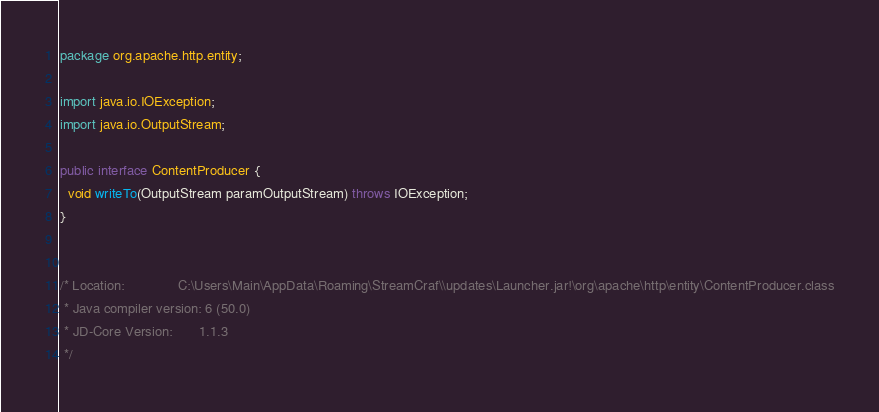<code> <loc_0><loc_0><loc_500><loc_500><_Java_>package org.apache.http.entity;

import java.io.IOException;
import java.io.OutputStream;

public interface ContentProducer {
  void writeTo(OutputStream paramOutputStream) throws IOException;
}


/* Location:              C:\Users\Main\AppData\Roaming\StreamCraf\\updates\Launcher.jar!\org\apache\http\entity\ContentProducer.class
 * Java compiler version: 6 (50.0)
 * JD-Core Version:       1.1.3
 */</code> 